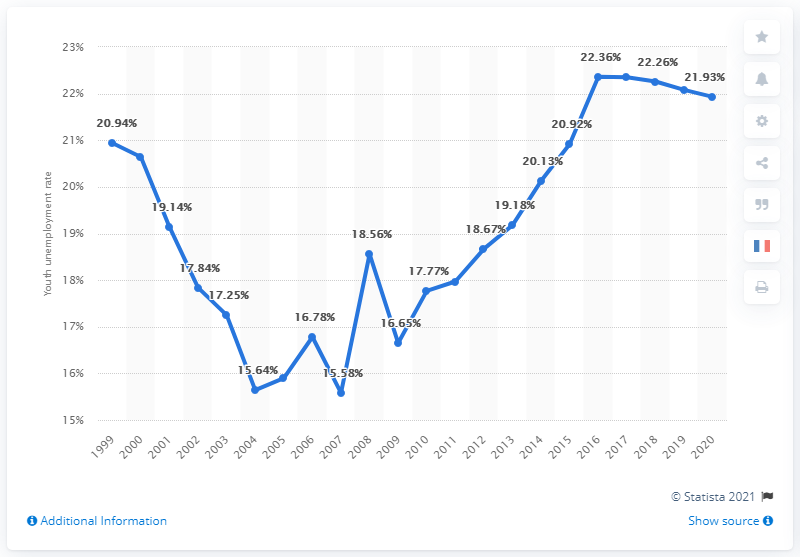Specify some key components in this picture. The youth unemployment rate in Morocco in 2020 was 21.93%. 